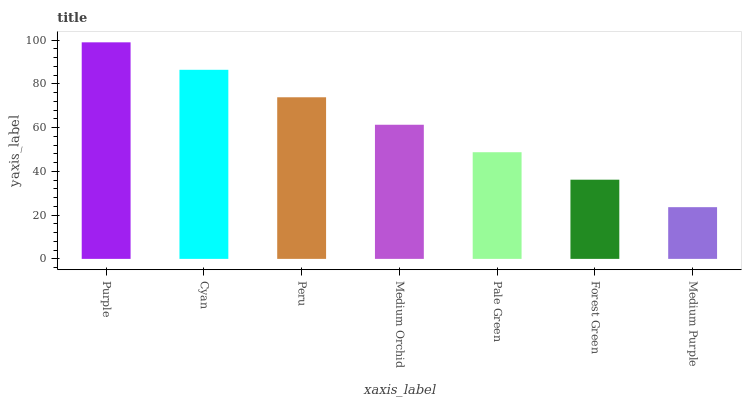Is Medium Purple the minimum?
Answer yes or no. Yes. Is Purple the maximum?
Answer yes or no. Yes. Is Cyan the minimum?
Answer yes or no. No. Is Cyan the maximum?
Answer yes or no. No. Is Purple greater than Cyan?
Answer yes or no. Yes. Is Cyan less than Purple?
Answer yes or no. Yes. Is Cyan greater than Purple?
Answer yes or no. No. Is Purple less than Cyan?
Answer yes or no. No. Is Medium Orchid the high median?
Answer yes or no. Yes. Is Medium Orchid the low median?
Answer yes or no. Yes. Is Pale Green the high median?
Answer yes or no. No. Is Purple the low median?
Answer yes or no. No. 